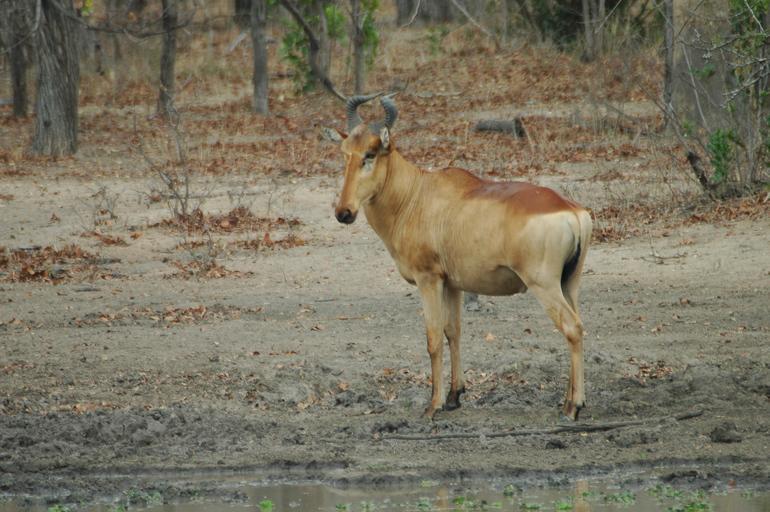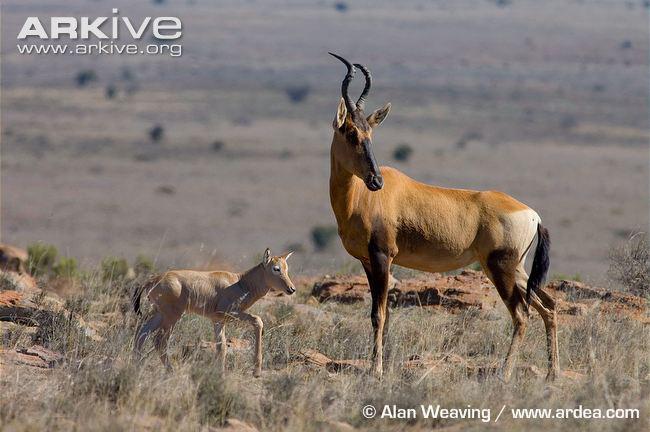The first image is the image on the left, the second image is the image on the right. Analyze the images presented: Is the assertion "The left and right image contains a total of three elk and the single elk facing left." valid? Answer yes or no. Yes. The first image is the image on the left, the second image is the image on the right. Given the left and right images, does the statement "A total of three animals with horns are standing still, and most have their heads turned to the camera." hold true? Answer yes or no. No. 